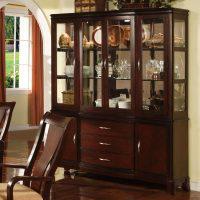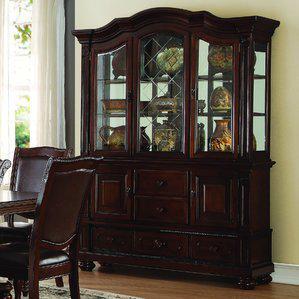The first image is the image on the left, the second image is the image on the right. For the images displayed, is the sentence "In one image in each pair there is white pottery on top of the china cabinet." factually correct? Answer yes or no. No. The first image is the image on the left, the second image is the image on the right. Evaluate the accuracy of this statement regarding the images: "the background has one picture hanging on the wall". Is it true? Answer yes or no. No. 